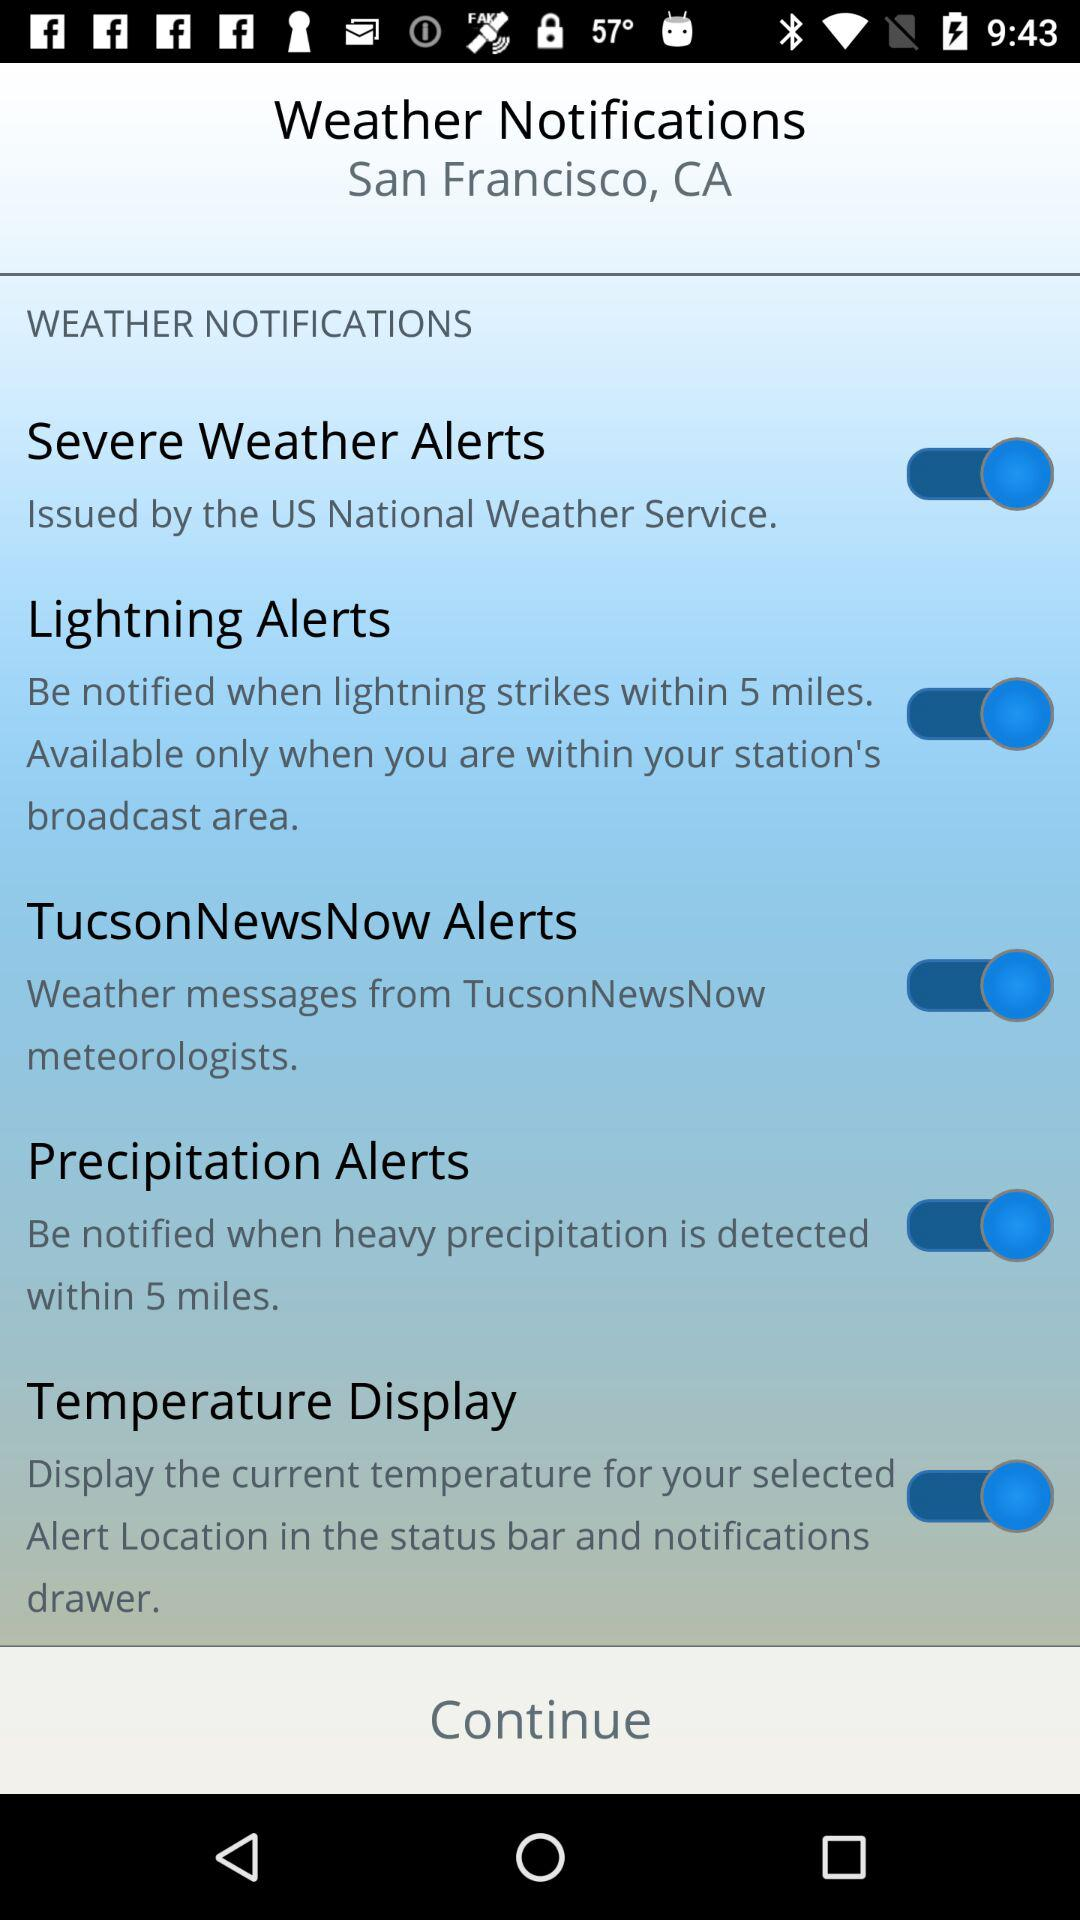What is the status of "Temperature Display"? The status of "Temperature Display" is "on". 